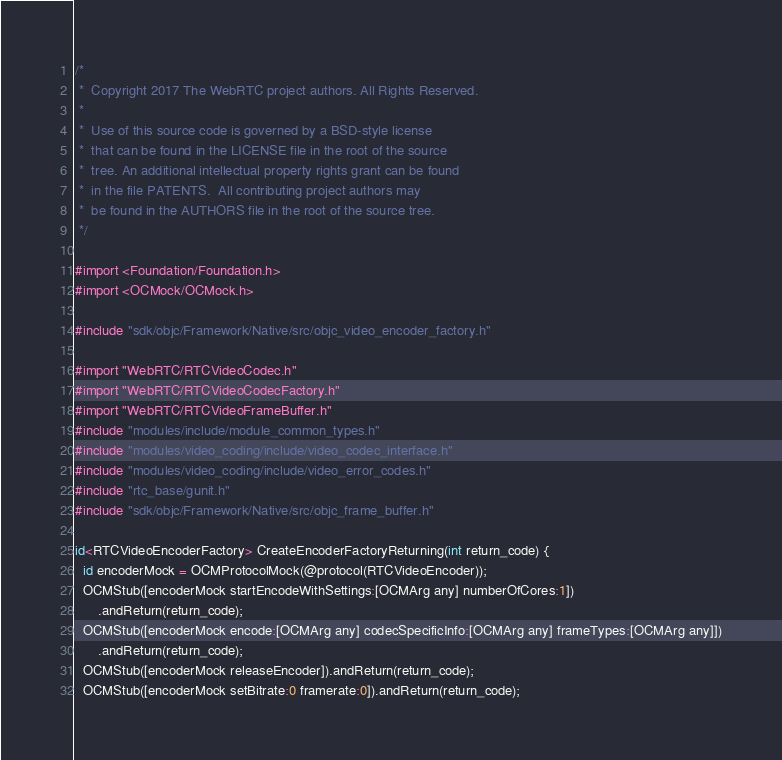Convert code to text. <code><loc_0><loc_0><loc_500><loc_500><_ObjectiveC_>/*
 *  Copyright 2017 The WebRTC project authors. All Rights Reserved.
 *
 *  Use of this source code is governed by a BSD-style license
 *  that can be found in the LICENSE file in the root of the source
 *  tree. An additional intellectual property rights grant can be found
 *  in the file PATENTS.  All contributing project authors may
 *  be found in the AUTHORS file in the root of the source tree.
 */

#import <Foundation/Foundation.h>
#import <OCMock/OCMock.h>

#include "sdk/objc/Framework/Native/src/objc_video_encoder_factory.h"

#import "WebRTC/RTCVideoCodec.h"
#import "WebRTC/RTCVideoCodecFactory.h"
#import "WebRTC/RTCVideoFrameBuffer.h"
#include "modules/include/module_common_types.h"
#include "modules/video_coding/include/video_codec_interface.h"
#include "modules/video_coding/include/video_error_codes.h"
#include "rtc_base/gunit.h"
#include "sdk/objc/Framework/Native/src/objc_frame_buffer.h"

id<RTCVideoEncoderFactory> CreateEncoderFactoryReturning(int return_code) {
  id encoderMock = OCMProtocolMock(@protocol(RTCVideoEncoder));
  OCMStub([encoderMock startEncodeWithSettings:[OCMArg any] numberOfCores:1])
      .andReturn(return_code);
  OCMStub([encoderMock encode:[OCMArg any] codecSpecificInfo:[OCMArg any] frameTypes:[OCMArg any]])
      .andReturn(return_code);
  OCMStub([encoderMock releaseEncoder]).andReturn(return_code);
  OCMStub([encoderMock setBitrate:0 framerate:0]).andReturn(return_code);
</code> 